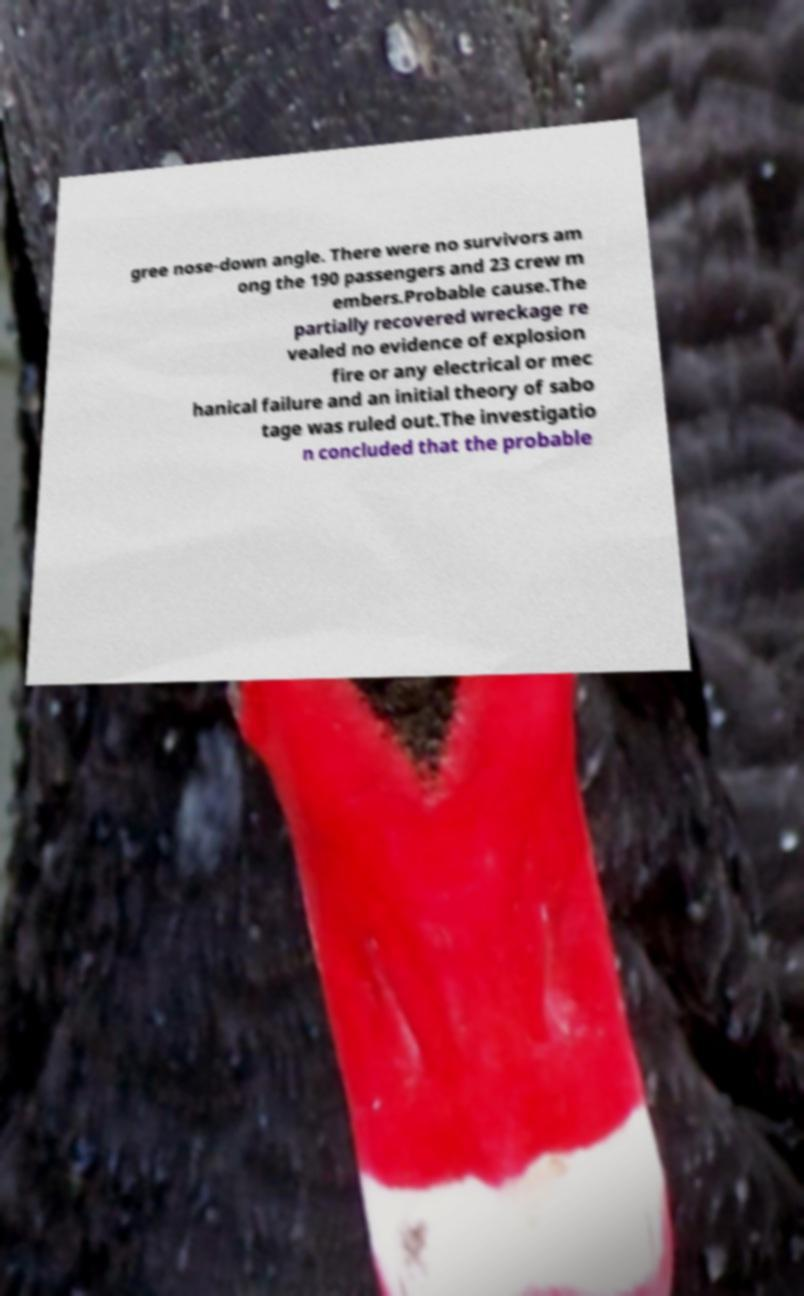Please identify and transcribe the text found in this image. gree nose-down angle. There were no survivors am ong the 190 passengers and 23 crew m embers.Probable cause.The partially recovered wreckage re vealed no evidence of explosion fire or any electrical or mec hanical failure and an initial theory of sabo tage was ruled out.The investigatio n concluded that the probable 